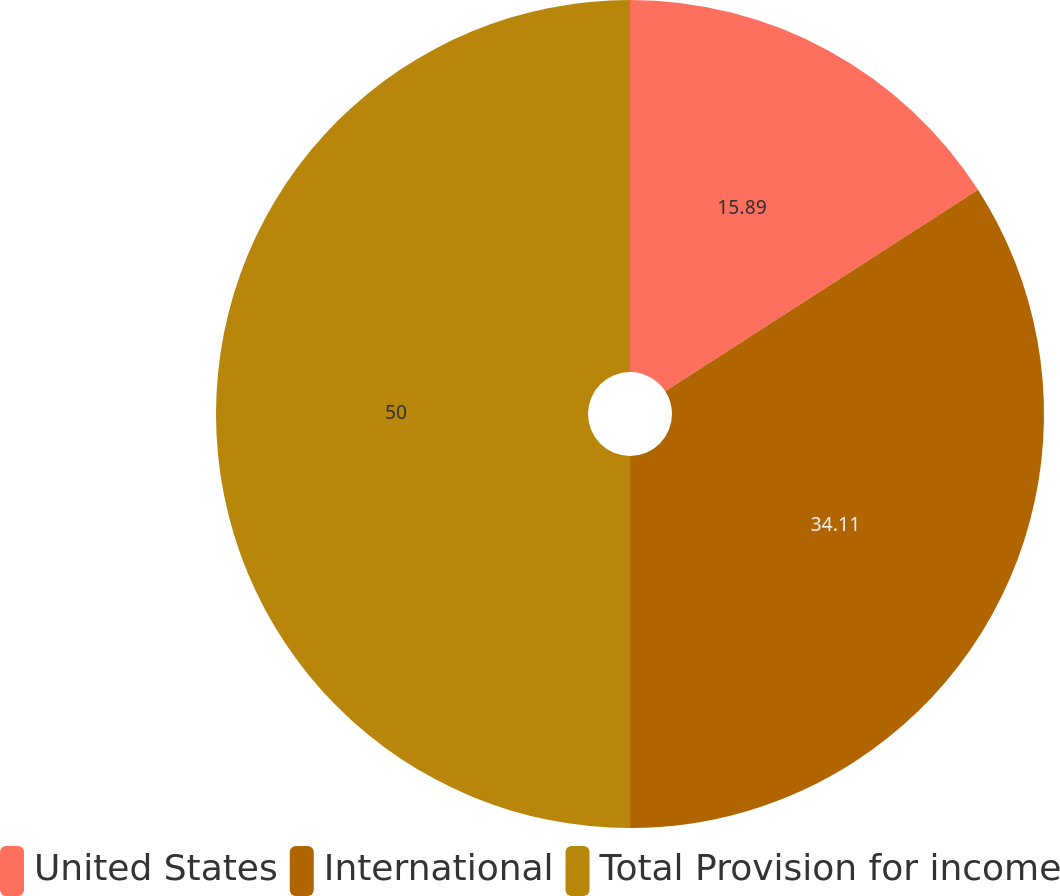Convert chart. <chart><loc_0><loc_0><loc_500><loc_500><pie_chart><fcel>United States<fcel>International<fcel>Total Provision for income<nl><fcel>15.89%<fcel>34.11%<fcel>50.0%<nl></chart> 